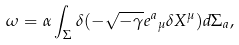Convert formula to latex. <formula><loc_0><loc_0><loc_500><loc_500>\omega = \alpha \int _ { \Sigma } \delta ( - \sqrt { - \gamma } e { ^ { a } } _ { \mu } \delta X ^ { \mu } ) d \Sigma _ { a } ,</formula> 